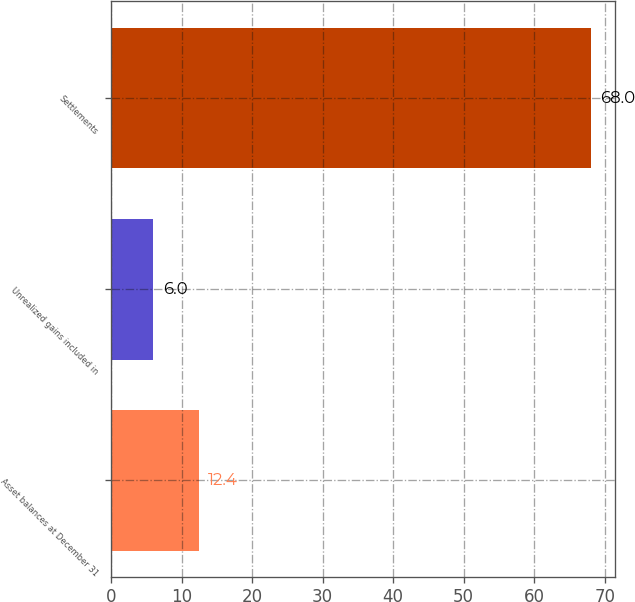Convert chart. <chart><loc_0><loc_0><loc_500><loc_500><bar_chart><fcel>Asset balances at December 31<fcel>Unrealized gains included in<fcel>Settlements<nl><fcel>12.4<fcel>6<fcel>68<nl></chart> 